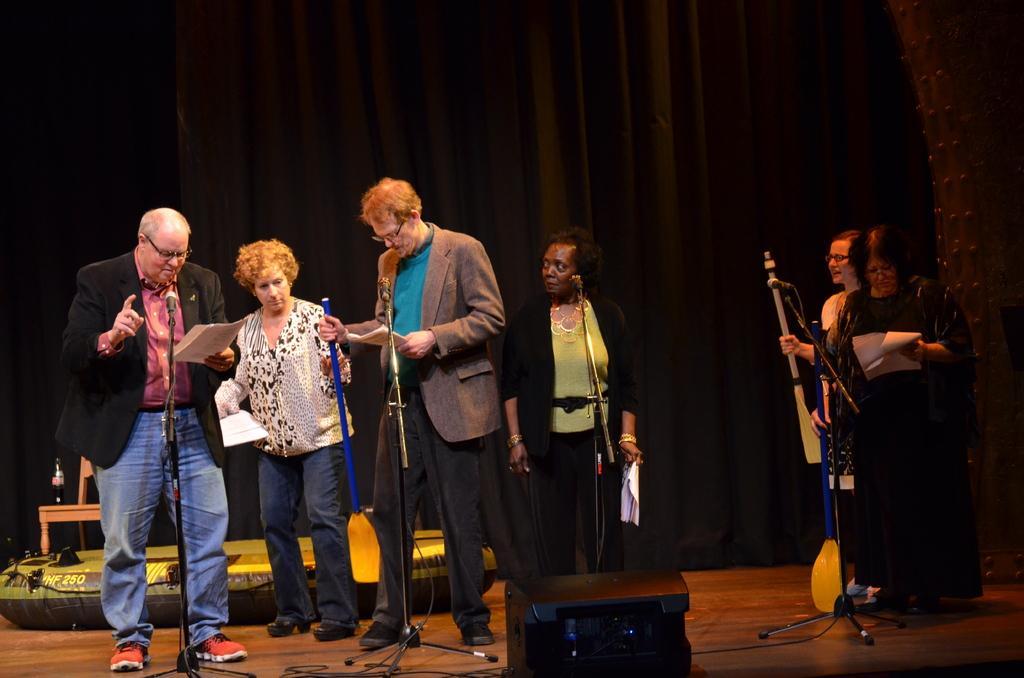In one or two sentences, can you explain what this image depicts? In this picture there are people, among them these five people are holding papers and these three people are holding paddles. We can see device, cables and object on the floor. In the background of the image it is dark and we can see bottle on a chair and curtains. 